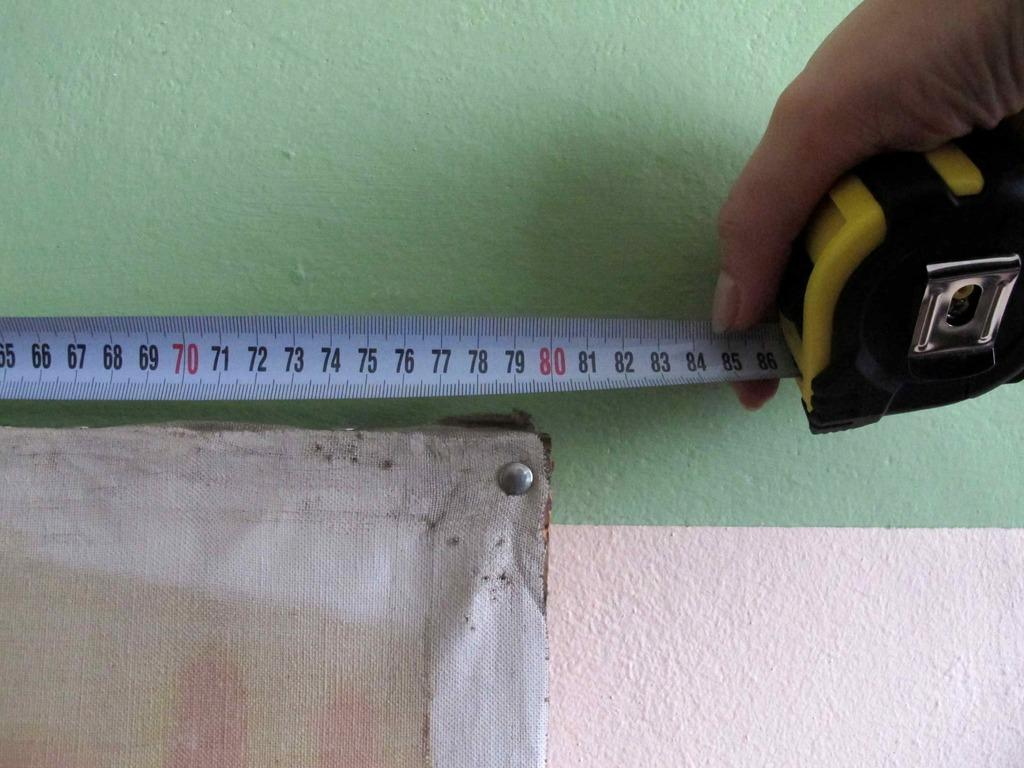Provide a one-sentence caption for the provided image. A hand holds a measuring tape with the number 86 showing at the very end of the tape. 